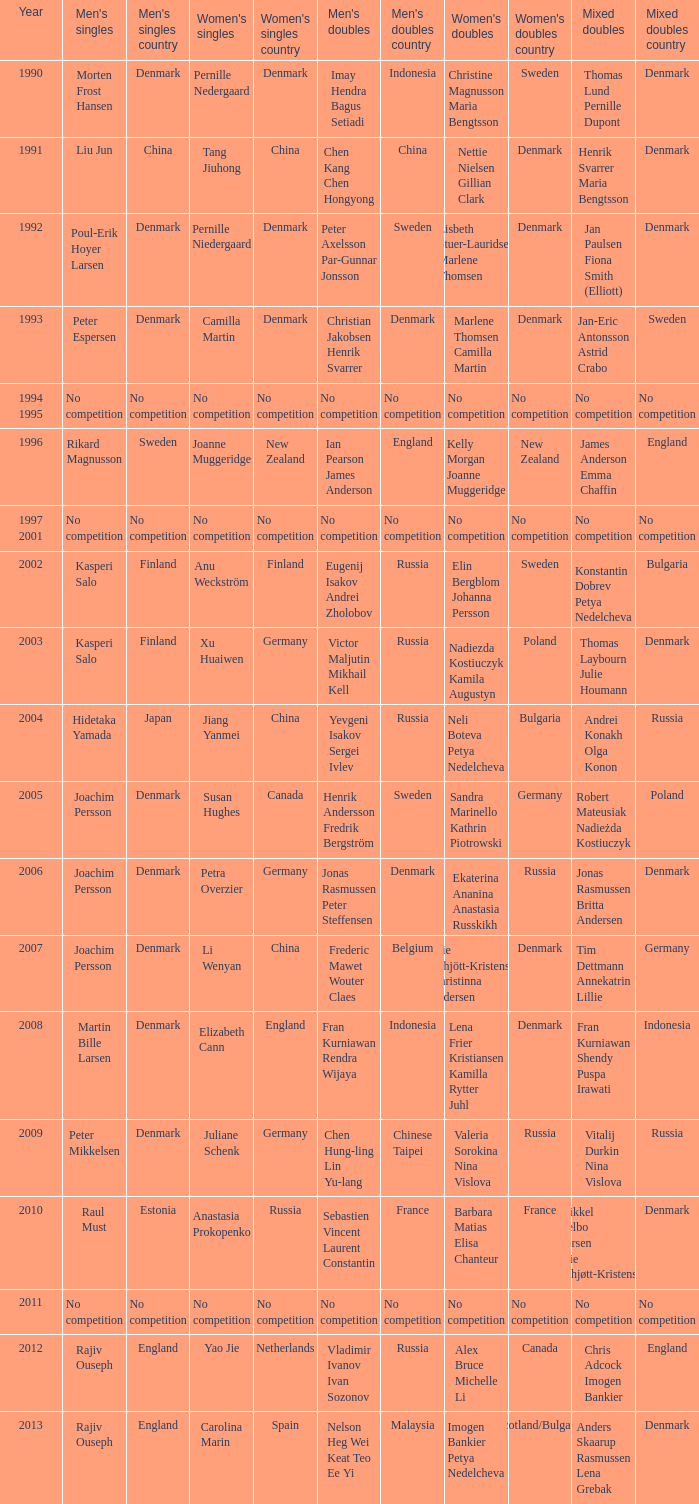During which year did carolina marin achieve a women's singles win? 2013.0. 